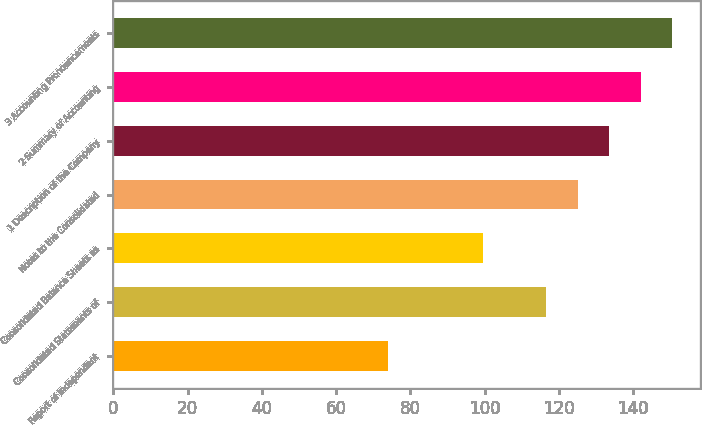Convert chart to OTSL. <chart><loc_0><loc_0><loc_500><loc_500><bar_chart><fcel>Report of Independent<fcel>Consolidated Statements of<fcel>Consolidated Balance Sheets as<fcel>Notes to the Consolidated<fcel>1 Description of the Company<fcel>2 Summary of Accounting<fcel>3 Accounting Pronouncements<nl><fcel>74<fcel>116.5<fcel>99.5<fcel>125<fcel>133.5<fcel>142<fcel>150.5<nl></chart> 